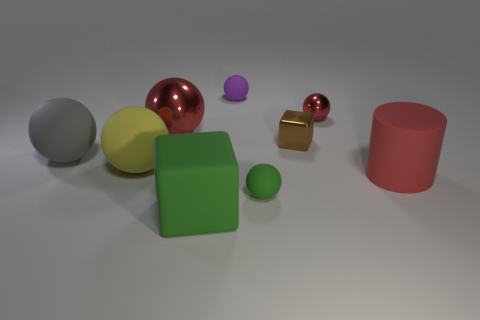What number of objects are small blue rubber things or small metallic things that are behind the brown object?
Offer a terse response. 1. What color is the big ball that is made of the same material as the small brown cube?
Your answer should be compact. Red. What number of things are red cylinders or tiny brown cubes?
Keep it short and to the point. 2. There is a cylinder that is the same size as the matte block; what is its color?
Provide a short and direct response. Red. What number of objects are either large cubes to the left of the small purple object or brown objects?
Provide a succinct answer. 2. How many other objects are there of the same size as the purple thing?
Provide a short and direct response. 3. What size is the rubber sphere in front of the big yellow matte sphere?
Offer a very short reply. Small. There is a small green thing that is made of the same material as the purple object; what is its shape?
Keep it short and to the point. Sphere. Is there anything else of the same color as the small block?
Your answer should be compact. No. There is a big object right of the red metal thing right of the matte cube; what color is it?
Make the answer very short. Red. 